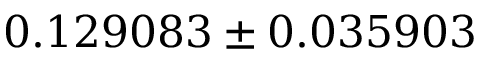Convert formula to latex. <formula><loc_0><loc_0><loc_500><loc_500>0 . 1 2 9 0 8 3 \pm 0 . 0 3 5 9 0 3</formula> 